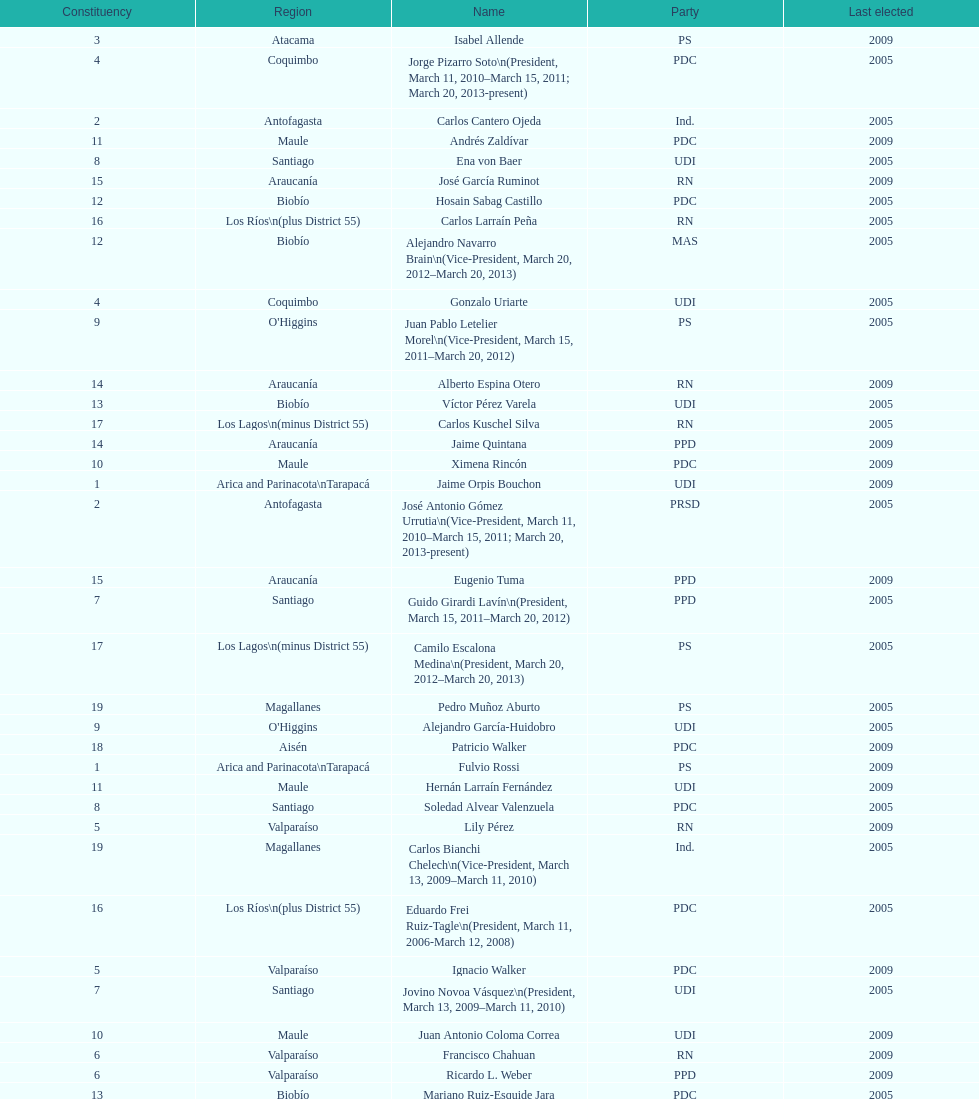In which party was jaime quintana involved? PPD. 